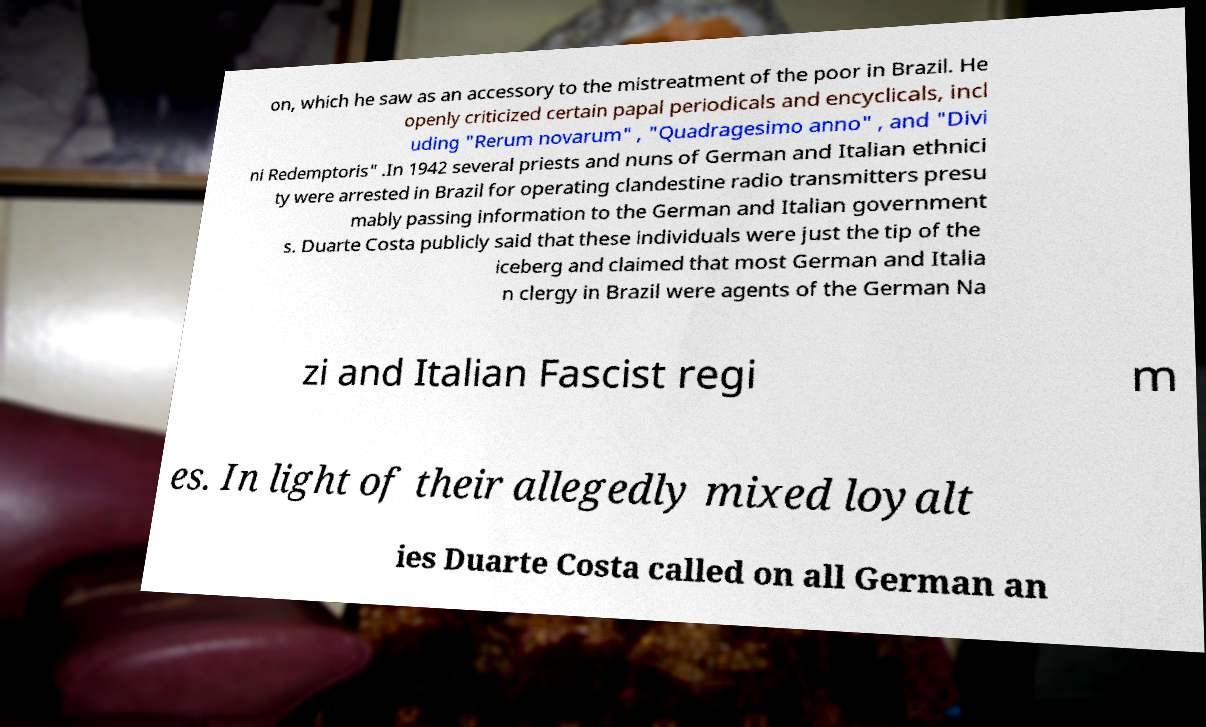Please read and relay the text visible in this image. What does it say? on, which he saw as an accessory to the mistreatment of the poor in Brazil. He openly criticized certain papal periodicals and encyclicals, incl uding "Rerum novarum" , "Quadragesimo anno" , and "Divi ni Redemptoris" .In 1942 several priests and nuns of German and Italian ethnici ty were arrested in Brazil for operating clandestine radio transmitters presu mably passing information to the German and Italian government s. Duarte Costa publicly said that these individuals were just the tip of the iceberg and claimed that most German and Italia n clergy in Brazil were agents of the German Na zi and Italian Fascist regi m es. In light of their allegedly mixed loyalt ies Duarte Costa called on all German an 